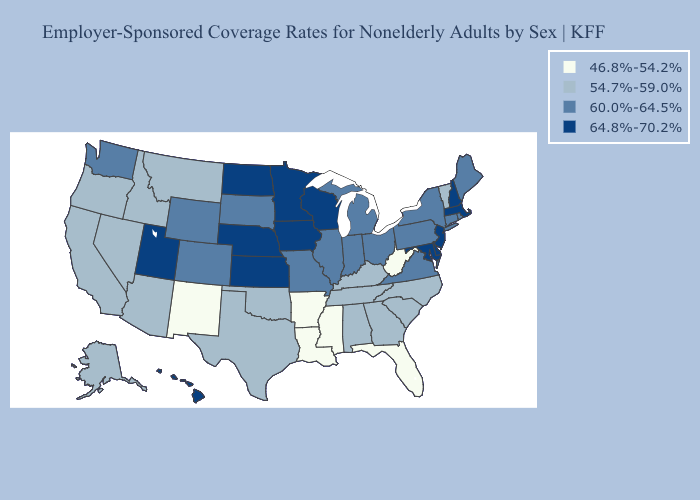Does Arkansas have the same value as Pennsylvania?
Quick response, please. No. Does Nevada have the highest value in the USA?
Keep it brief. No. Among the states that border Oklahoma , which have the lowest value?
Keep it brief. Arkansas, New Mexico. Is the legend a continuous bar?
Be succinct. No. Name the states that have a value in the range 60.0%-64.5%?
Give a very brief answer. Colorado, Connecticut, Illinois, Indiana, Maine, Michigan, Missouri, New York, Ohio, Pennsylvania, Rhode Island, South Dakota, Virginia, Washington, Wyoming. Name the states that have a value in the range 54.7%-59.0%?
Short answer required. Alabama, Alaska, Arizona, California, Georgia, Idaho, Kentucky, Montana, Nevada, North Carolina, Oklahoma, Oregon, South Carolina, Tennessee, Texas, Vermont. What is the lowest value in the South?
Concise answer only. 46.8%-54.2%. What is the value of North Carolina?
Be succinct. 54.7%-59.0%. What is the value of Oklahoma?
Short answer required. 54.7%-59.0%. Name the states that have a value in the range 64.8%-70.2%?
Write a very short answer. Delaware, Hawaii, Iowa, Kansas, Maryland, Massachusetts, Minnesota, Nebraska, New Hampshire, New Jersey, North Dakota, Utah, Wisconsin. Does California have the highest value in the West?
Quick response, please. No. Does Rhode Island have the same value as Washington?
Give a very brief answer. Yes. What is the lowest value in the MidWest?
Give a very brief answer. 60.0%-64.5%. What is the value of Kentucky?
Answer briefly. 54.7%-59.0%. Which states hav the highest value in the South?
Short answer required. Delaware, Maryland. 